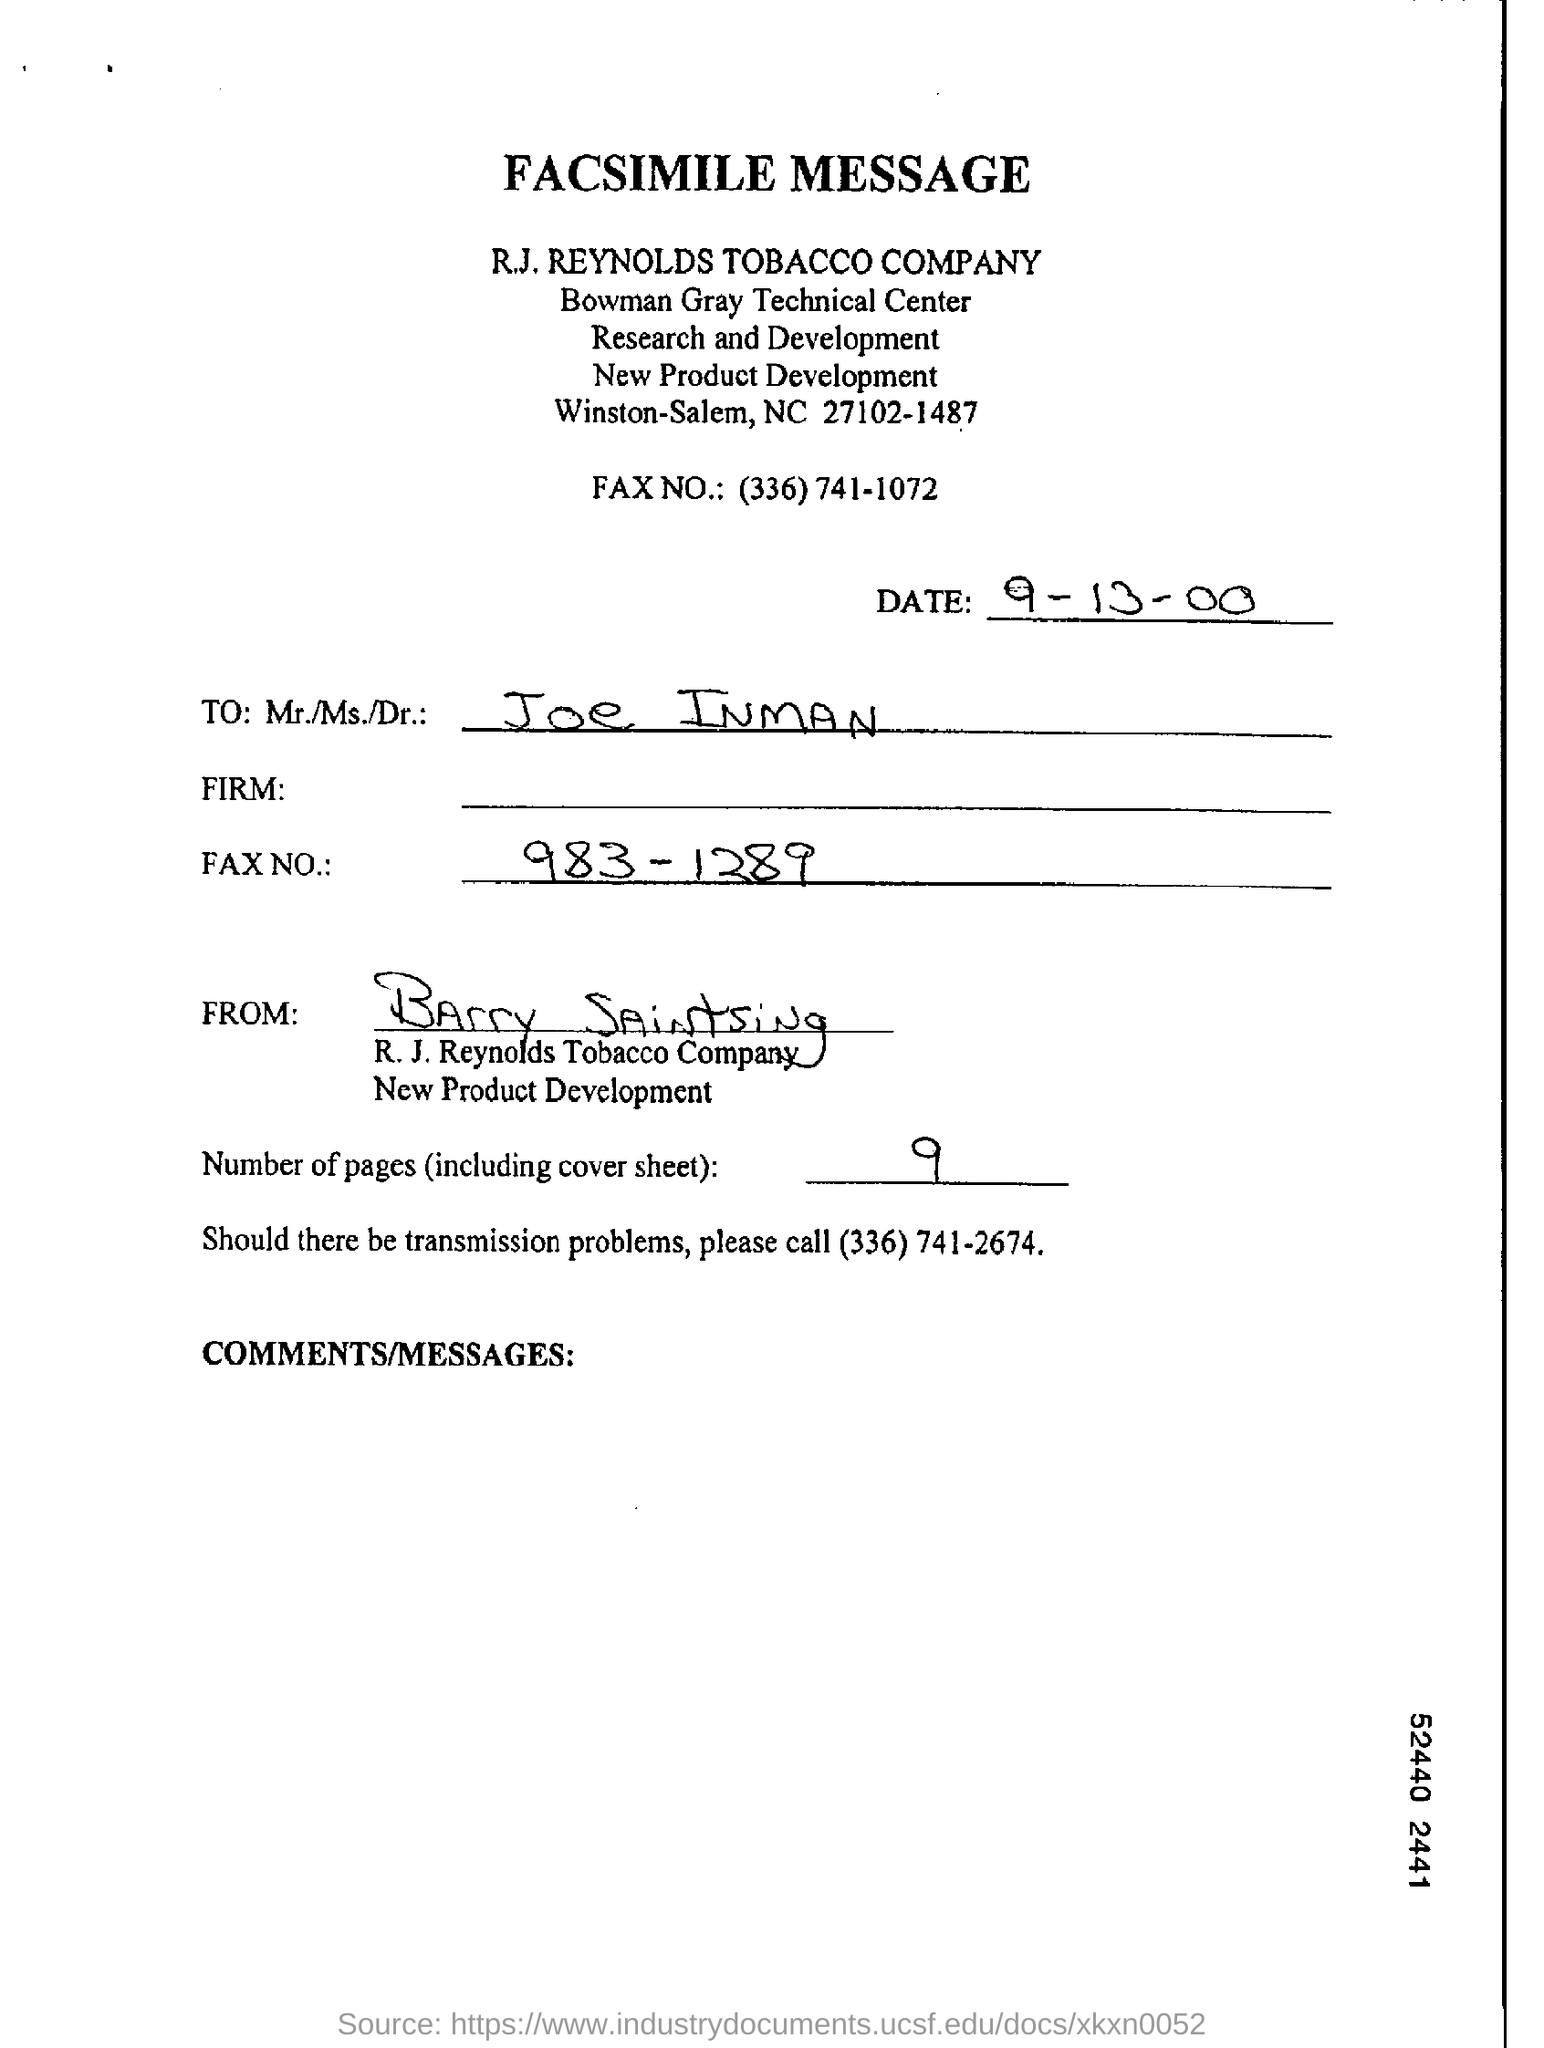Identify some key points in this picture. The letter is addressed to Joe Inman. The letter is from Barry Saintsing. The date on the document is September 13, 2000. 